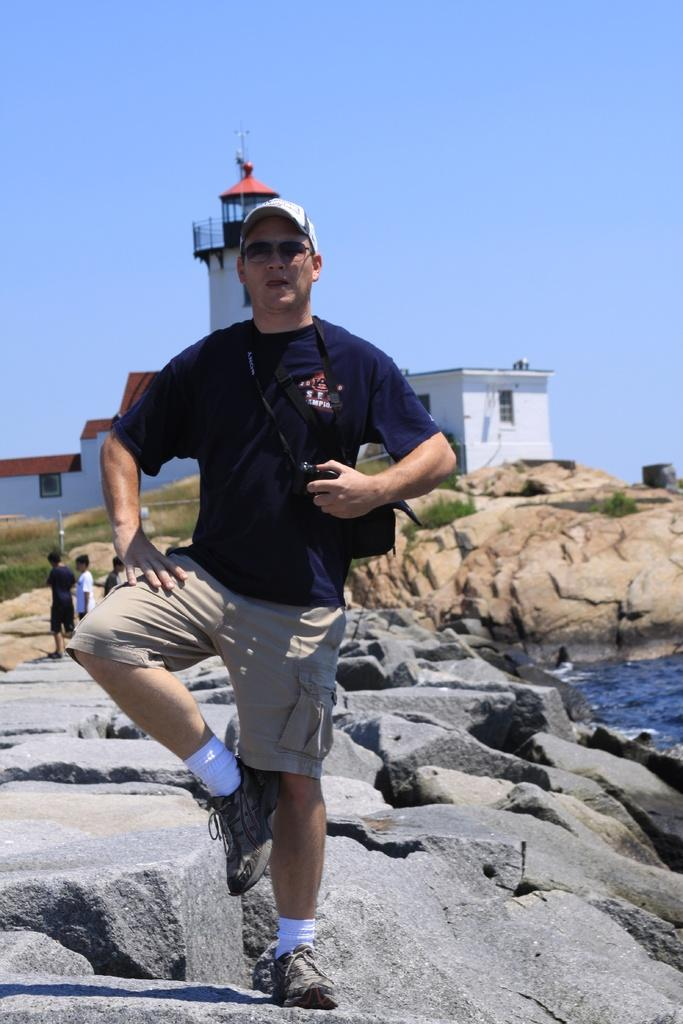What is the person in the image doing? The person is standing on stones in the image. What structures can be seen in the background? There are buildings in the image. Are there any other people present in the image? Yes, there are people in the image. What type of natural elements are visible in the image? There are rocks in the image. What is visible in the upper part of the image? The sky is visible in the image. What type of pen is the stranger holding in the image? There is no stranger or pen present in the image. 